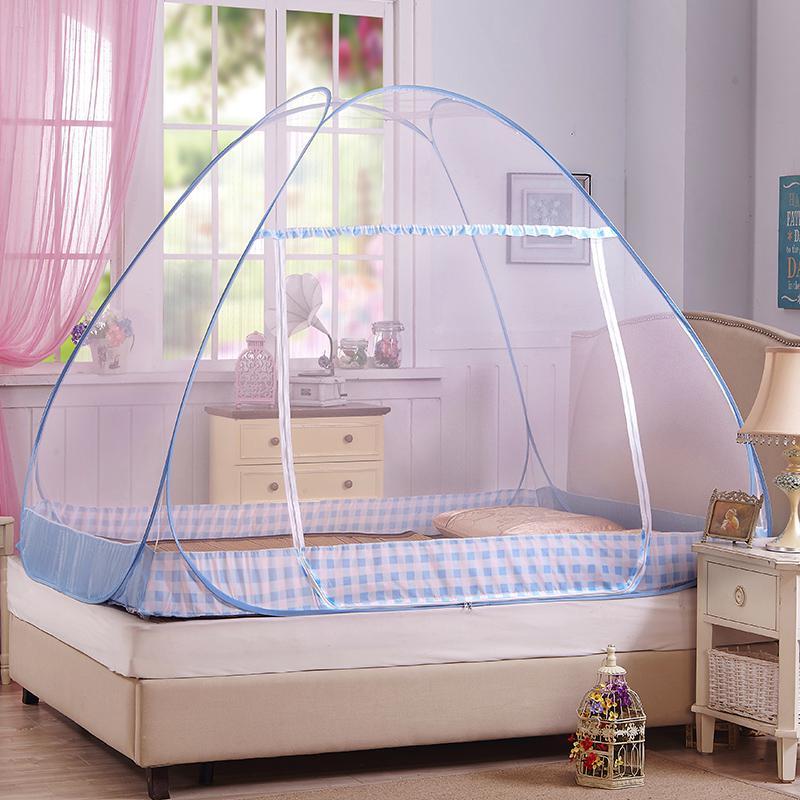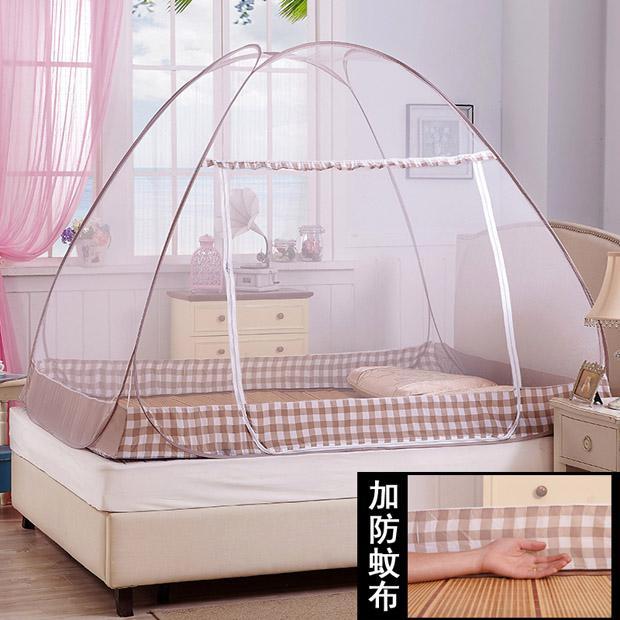The first image is the image on the left, the second image is the image on the right. Considering the images on both sides, is "A bed has a blue-trimmed canopy with a band of patterned fabric around the base." valid? Answer yes or no. Yes. 